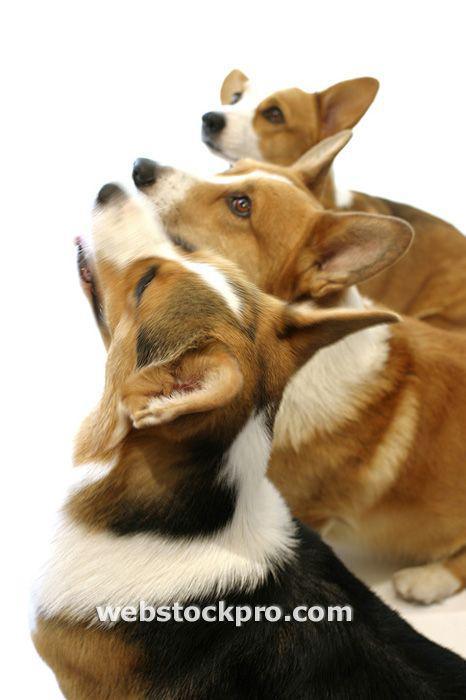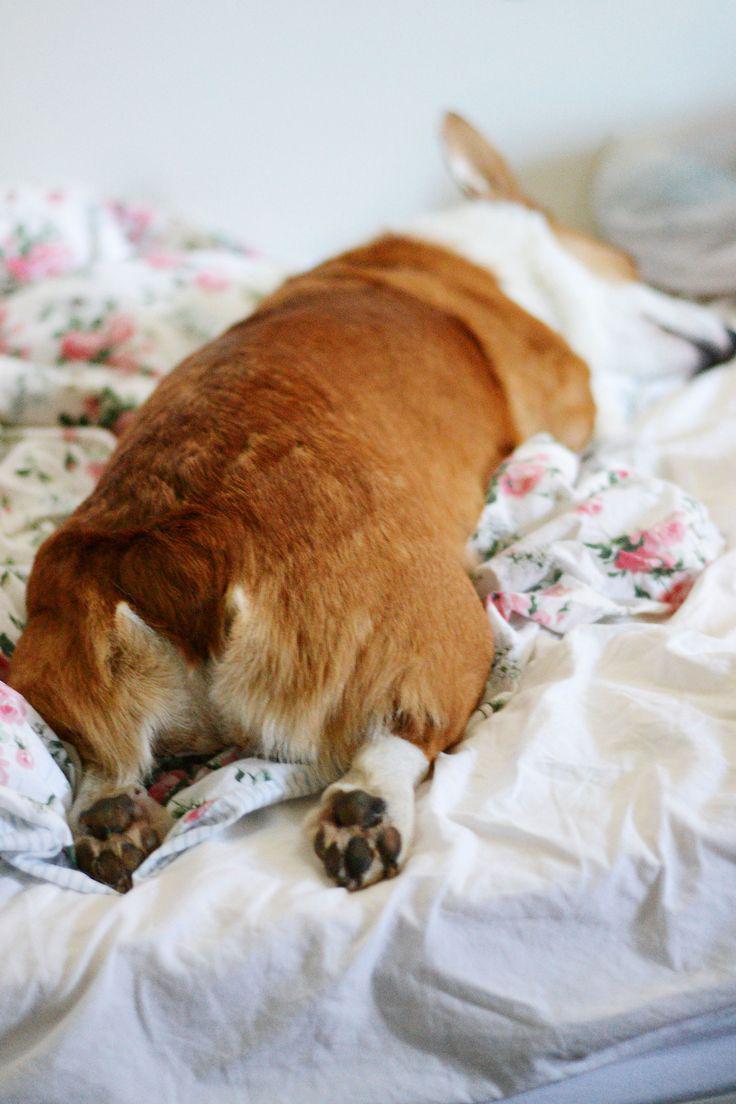The first image is the image on the left, the second image is the image on the right. Analyze the images presented: Is the assertion "An image shows one orange-and-white dog, which is sprawling flat on its belly." valid? Answer yes or no. Yes. The first image is the image on the left, the second image is the image on the right. For the images shown, is this caption "There are three dogs in total." true? Answer yes or no. No. 